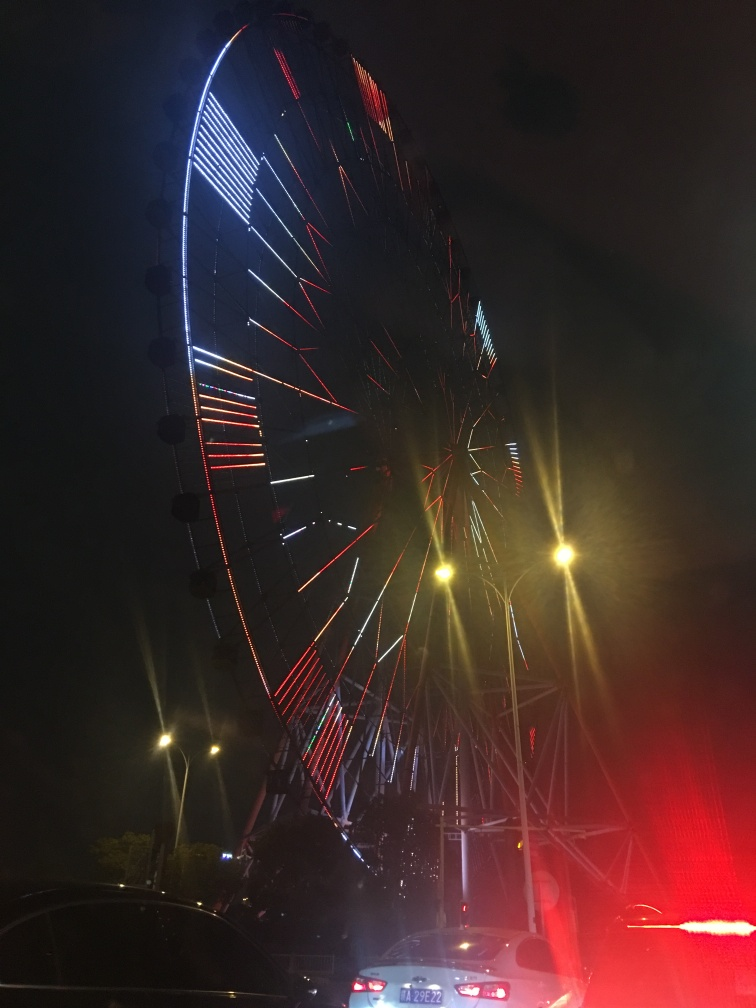What time of day was this photo taken? The photo appears to have been taken at night, as the sky is dark and the ferris wheel is illuminated with vibrant lights. 